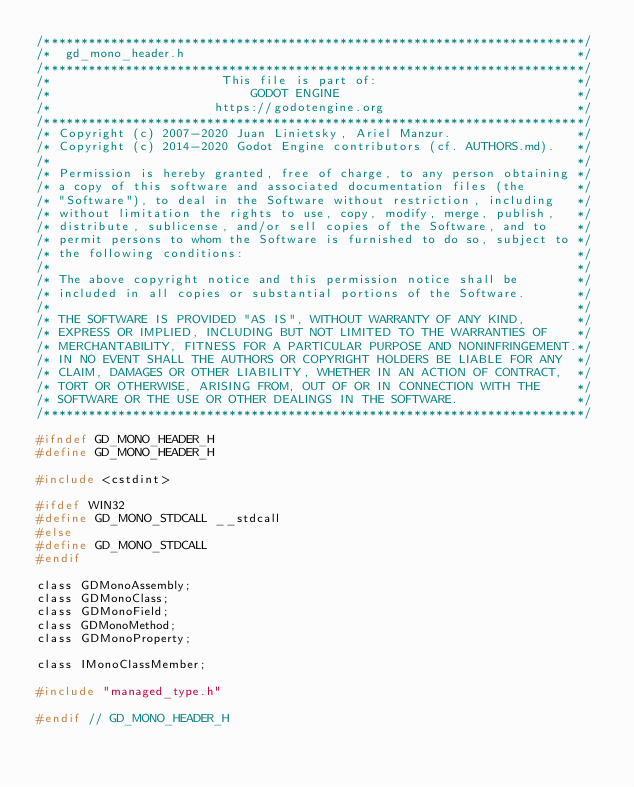<code> <loc_0><loc_0><loc_500><loc_500><_C_>/*************************************************************************/
/*  gd_mono_header.h                                                     */
/*************************************************************************/
/*                       This file is part of:                           */
/*                           GODOT ENGINE                                */
/*                      https://godotengine.org                          */
/*************************************************************************/
/* Copyright (c) 2007-2020 Juan Linietsky, Ariel Manzur.                 */
/* Copyright (c) 2014-2020 Godot Engine contributors (cf. AUTHORS.md).   */
/*                                                                       */
/* Permission is hereby granted, free of charge, to any person obtaining */
/* a copy of this software and associated documentation files (the       */
/* "Software"), to deal in the Software without restriction, including   */
/* without limitation the rights to use, copy, modify, merge, publish,   */
/* distribute, sublicense, and/or sell copies of the Software, and to    */
/* permit persons to whom the Software is furnished to do so, subject to */
/* the following conditions:                                             */
/*                                                                       */
/* The above copyright notice and this permission notice shall be        */
/* included in all copies or substantial portions of the Software.       */
/*                                                                       */
/* THE SOFTWARE IS PROVIDED "AS IS", WITHOUT WARRANTY OF ANY KIND,       */
/* EXPRESS OR IMPLIED, INCLUDING BUT NOT LIMITED TO THE WARRANTIES OF    */
/* MERCHANTABILITY, FITNESS FOR A PARTICULAR PURPOSE AND NONINFRINGEMENT.*/
/* IN NO EVENT SHALL THE AUTHORS OR COPYRIGHT HOLDERS BE LIABLE FOR ANY  */
/* CLAIM, DAMAGES OR OTHER LIABILITY, WHETHER IN AN ACTION OF CONTRACT,  */
/* TORT OR OTHERWISE, ARISING FROM, OUT OF OR IN CONNECTION WITH THE     */
/* SOFTWARE OR THE USE OR OTHER DEALINGS IN THE SOFTWARE.                */
/*************************************************************************/

#ifndef GD_MONO_HEADER_H
#define GD_MONO_HEADER_H

#include <cstdint>

#ifdef WIN32
#define GD_MONO_STDCALL __stdcall
#else
#define GD_MONO_STDCALL
#endif

class GDMonoAssembly;
class GDMonoClass;
class GDMonoField;
class GDMonoMethod;
class GDMonoProperty;

class IMonoClassMember;

#include "managed_type.h"

#endif // GD_MONO_HEADER_H
</code> 